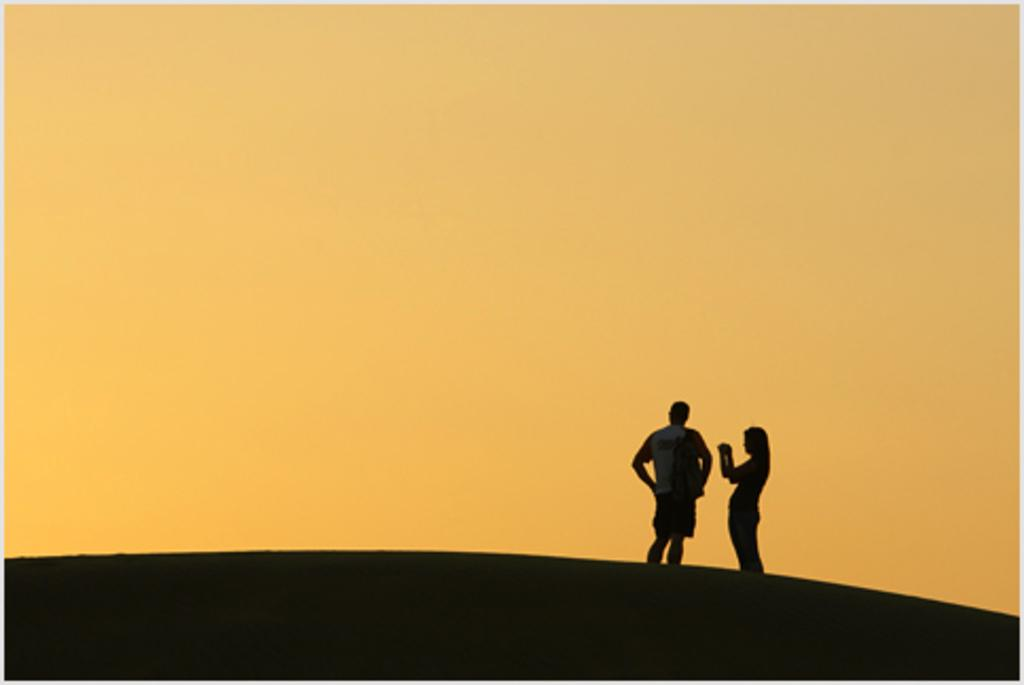What is the man doing in the image? The man is standing in the image. What is the man wearing in the image? The man is wearing a bag in the image. What is the woman doing in the image? The woman is taking a photo in the image. What can be seen in the background of the image? The sky is visible in the background of the image. What type of air is being used to cook the stew in the image? There is no stew or cooking activity present in the image. 